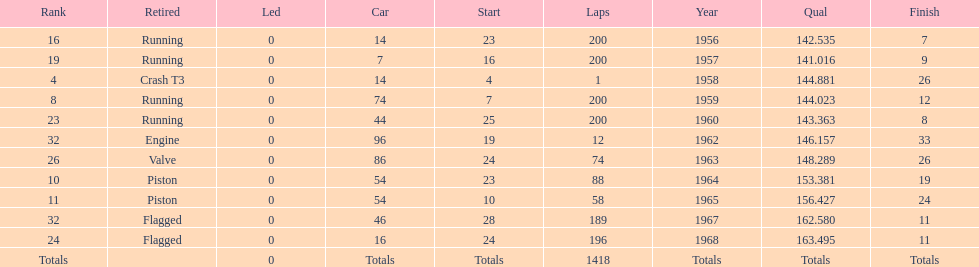How many times was bob veith ranked higher than 10 at an indy 500? 2. Parse the full table. {'header': ['Rank', 'Retired', 'Led', 'Car', 'Start', 'Laps', 'Year', 'Qual', 'Finish'], 'rows': [['16', 'Running', '0', '14', '23', '200', '1956', '142.535', '7'], ['19', 'Running', '0', '7', '16', '200', '1957', '141.016', '9'], ['4', 'Crash T3', '0', '14', '4', '1', '1958', '144.881', '26'], ['8', 'Running', '0', '74', '7', '200', '1959', '144.023', '12'], ['23', 'Running', '0', '44', '25', '200', '1960', '143.363', '8'], ['32', 'Engine', '0', '96', '19', '12', '1962', '146.157', '33'], ['26', 'Valve', '0', '86', '24', '74', '1963', '148.289', '26'], ['10', 'Piston', '0', '54', '23', '88', '1964', '153.381', '19'], ['11', 'Piston', '0', '54', '10', '58', '1965', '156.427', '24'], ['32', 'Flagged', '0', '46', '28', '189', '1967', '162.580', '11'], ['24', 'Flagged', '0', '16', '24', '196', '1968', '163.495', '11'], ['Totals', '', '0', 'Totals', 'Totals', '1418', 'Totals', 'Totals', 'Totals']]} 